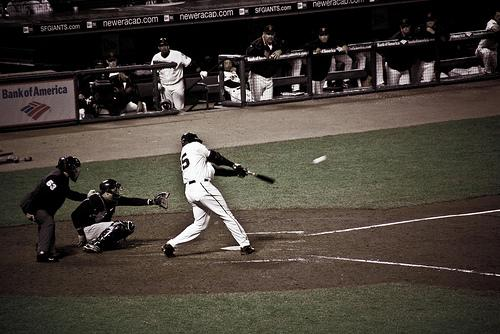Question: what is white?
Choices:
A. Snow.
B. The toilet.
C. Uniform.
D. The walls.
Answer with the letter. Answer: C Question: who hit the ball?
Choices:
A. The boy.
B. The man.
C. The girl.
D. Batter.
Answer with the letter. Answer: D Question: how many players?
Choices:
A. Two.
B. Four.
C. Six.
D. Eight.
Answer with the letter. Answer: A Question: what time was the picture taken?
Choices:
A. Daytime.
B. At 3:10.
C. Nighttime.
D. At sunset.
Answer with the letter. Answer: C Question: what game is this?
Choices:
A. Hockey.
B. Football.
C. Basketball.
D. Baseball.
Answer with the letter. Answer: D 